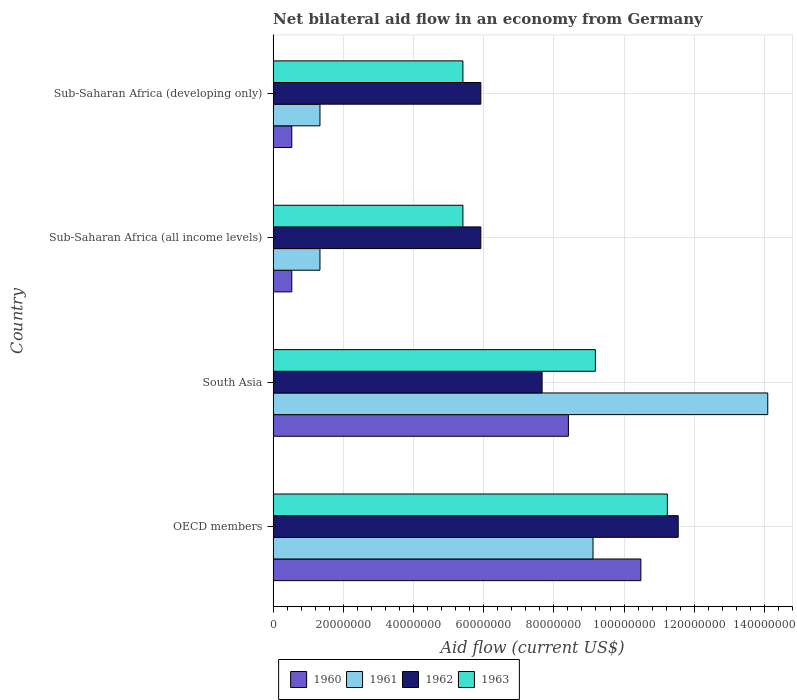Are the number of bars on each tick of the Y-axis equal?
Offer a terse response. Yes. How many bars are there on the 2nd tick from the top?
Your response must be concise. 4. What is the label of the 2nd group of bars from the top?
Offer a very short reply. Sub-Saharan Africa (all income levels). What is the net bilateral aid flow in 1961 in OECD members?
Offer a terse response. 9.12e+07. Across all countries, what is the maximum net bilateral aid flow in 1961?
Give a very brief answer. 1.41e+08. Across all countries, what is the minimum net bilateral aid flow in 1961?
Your response must be concise. 1.34e+07. In which country was the net bilateral aid flow in 1962 maximum?
Keep it short and to the point. OECD members. In which country was the net bilateral aid flow in 1962 minimum?
Your answer should be compact. Sub-Saharan Africa (all income levels). What is the total net bilateral aid flow in 1961 in the graph?
Keep it short and to the point. 2.59e+08. What is the difference between the net bilateral aid flow in 1961 in OECD members and that in South Asia?
Give a very brief answer. -4.98e+07. What is the difference between the net bilateral aid flow in 1962 in South Asia and the net bilateral aid flow in 1963 in OECD members?
Your answer should be compact. -3.57e+07. What is the average net bilateral aid flow in 1962 per country?
Ensure brevity in your answer.  7.76e+07. What is the difference between the net bilateral aid flow in 1961 and net bilateral aid flow in 1960 in Sub-Saharan Africa (developing only)?
Provide a succinct answer. 8.03e+06. In how many countries, is the net bilateral aid flow in 1960 greater than 20000000 US$?
Provide a succinct answer. 2. What is the ratio of the net bilateral aid flow in 1962 in OECD members to that in South Asia?
Make the answer very short. 1.51. Is the difference between the net bilateral aid flow in 1961 in OECD members and Sub-Saharan Africa (all income levels) greater than the difference between the net bilateral aid flow in 1960 in OECD members and Sub-Saharan Africa (all income levels)?
Offer a terse response. No. What is the difference between the highest and the second highest net bilateral aid flow in 1963?
Ensure brevity in your answer.  2.05e+07. What is the difference between the highest and the lowest net bilateral aid flow in 1963?
Make the answer very short. 5.83e+07. In how many countries, is the net bilateral aid flow in 1961 greater than the average net bilateral aid flow in 1961 taken over all countries?
Provide a succinct answer. 2. What does the 2nd bar from the top in Sub-Saharan Africa (all income levels) represents?
Give a very brief answer. 1962. What does the 4th bar from the bottom in South Asia represents?
Make the answer very short. 1963. Is it the case that in every country, the sum of the net bilateral aid flow in 1963 and net bilateral aid flow in 1960 is greater than the net bilateral aid flow in 1961?
Keep it short and to the point. Yes. How many bars are there?
Your response must be concise. 16. How many countries are there in the graph?
Give a very brief answer. 4. Are the values on the major ticks of X-axis written in scientific E-notation?
Offer a terse response. No. Does the graph contain grids?
Your answer should be compact. Yes. How many legend labels are there?
Make the answer very short. 4. What is the title of the graph?
Your answer should be very brief. Net bilateral aid flow in an economy from Germany. What is the Aid flow (current US$) in 1960 in OECD members?
Offer a very short reply. 1.05e+08. What is the Aid flow (current US$) of 1961 in OECD members?
Make the answer very short. 9.12e+07. What is the Aid flow (current US$) in 1962 in OECD members?
Keep it short and to the point. 1.15e+08. What is the Aid flow (current US$) in 1963 in OECD members?
Ensure brevity in your answer.  1.12e+08. What is the Aid flow (current US$) of 1960 in South Asia?
Make the answer very short. 8.42e+07. What is the Aid flow (current US$) in 1961 in South Asia?
Offer a very short reply. 1.41e+08. What is the Aid flow (current US$) of 1962 in South Asia?
Ensure brevity in your answer.  7.66e+07. What is the Aid flow (current US$) of 1963 in South Asia?
Make the answer very short. 9.18e+07. What is the Aid flow (current US$) in 1960 in Sub-Saharan Africa (all income levels)?
Your answer should be compact. 5.32e+06. What is the Aid flow (current US$) of 1961 in Sub-Saharan Africa (all income levels)?
Your response must be concise. 1.34e+07. What is the Aid flow (current US$) of 1962 in Sub-Saharan Africa (all income levels)?
Your answer should be very brief. 5.92e+07. What is the Aid flow (current US$) of 1963 in Sub-Saharan Africa (all income levels)?
Ensure brevity in your answer.  5.41e+07. What is the Aid flow (current US$) in 1960 in Sub-Saharan Africa (developing only)?
Give a very brief answer. 5.32e+06. What is the Aid flow (current US$) of 1961 in Sub-Saharan Africa (developing only)?
Ensure brevity in your answer.  1.34e+07. What is the Aid flow (current US$) of 1962 in Sub-Saharan Africa (developing only)?
Provide a succinct answer. 5.92e+07. What is the Aid flow (current US$) in 1963 in Sub-Saharan Africa (developing only)?
Your answer should be very brief. 5.41e+07. Across all countries, what is the maximum Aid flow (current US$) of 1960?
Offer a terse response. 1.05e+08. Across all countries, what is the maximum Aid flow (current US$) in 1961?
Make the answer very short. 1.41e+08. Across all countries, what is the maximum Aid flow (current US$) in 1962?
Offer a very short reply. 1.15e+08. Across all countries, what is the maximum Aid flow (current US$) in 1963?
Offer a very short reply. 1.12e+08. Across all countries, what is the minimum Aid flow (current US$) of 1960?
Offer a very short reply. 5.32e+06. Across all countries, what is the minimum Aid flow (current US$) of 1961?
Your answer should be compact. 1.34e+07. Across all countries, what is the minimum Aid flow (current US$) in 1962?
Offer a terse response. 5.92e+07. Across all countries, what is the minimum Aid flow (current US$) of 1963?
Provide a short and direct response. 5.41e+07. What is the total Aid flow (current US$) of 1960 in the graph?
Your answer should be compact. 2.00e+08. What is the total Aid flow (current US$) of 1961 in the graph?
Ensure brevity in your answer.  2.59e+08. What is the total Aid flow (current US$) in 1962 in the graph?
Offer a terse response. 3.10e+08. What is the total Aid flow (current US$) of 1963 in the graph?
Make the answer very short. 3.12e+08. What is the difference between the Aid flow (current US$) in 1960 in OECD members and that in South Asia?
Keep it short and to the point. 2.06e+07. What is the difference between the Aid flow (current US$) of 1961 in OECD members and that in South Asia?
Keep it short and to the point. -4.98e+07. What is the difference between the Aid flow (current US$) of 1962 in OECD members and that in South Asia?
Offer a very short reply. 3.88e+07. What is the difference between the Aid flow (current US$) of 1963 in OECD members and that in South Asia?
Your response must be concise. 2.05e+07. What is the difference between the Aid flow (current US$) in 1960 in OECD members and that in Sub-Saharan Africa (all income levels)?
Your answer should be very brief. 9.95e+07. What is the difference between the Aid flow (current US$) in 1961 in OECD members and that in Sub-Saharan Africa (all income levels)?
Ensure brevity in your answer.  7.78e+07. What is the difference between the Aid flow (current US$) in 1962 in OECD members and that in Sub-Saharan Africa (all income levels)?
Your answer should be compact. 5.62e+07. What is the difference between the Aid flow (current US$) in 1963 in OECD members and that in Sub-Saharan Africa (all income levels)?
Your answer should be compact. 5.83e+07. What is the difference between the Aid flow (current US$) in 1960 in OECD members and that in Sub-Saharan Africa (developing only)?
Give a very brief answer. 9.95e+07. What is the difference between the Aid flow (current US$) in 1961 in OECD members and that in Sub-Saharan Africa (developing only)?
Provide a short and direct response. 7.78e+07. What is the difference between the Aid flow (current US$) in 1962 in OECD members and that in Sub-Saharan Africa (developing only)?
Make the answer very short. 5.62e+07. What is the difference between the Aid flow (current US$) of 1963 in OECD members and that in Sub-Saharan Africa (developing only)?
Offer a terse response. 5.83e+07. What is the difference between the Aid flow (current US$) in 1960 in South Asia and that in Sub-Saharan Africa (all income levels)?
Keep it short and to the point. 7.88e+07. What is the difference between the Aid flow (current US$) of 1961 in South Asia and that in Sub-Saharan Africa (all income levels)?
Your answer should be very brief. 1.28e+08. What is the difference between the Aid flow (current US$) in 1962 in South Asia and that in Sub-Saharan Africa (all income levels)?
Provide a succinct answer. 1.75e+07. What is the difference between the Aid flow (current US$) of 1963 in South Asia and that in Sub-Saharan Africa (all income levels)?
Ensure brevity in your answer.  3.78e+07. What is the difference between the Aid flow (current US$) in 1960 in South Asia and that in Sub-Saharan Africa (developing only)?
Give a very brief answer. 7.88e+07. What is the difference between the Aid flow (current US$) of 1961 in South Asia and that in Sub-Saharan Africa (developing only)?
Give a very brief answer. 1.28e+08. What is the difference between the Aid flow (current US$) in 1962 in South Asia and that in Sub-Saharan Africa (developing only)?
Your response must be concise. 1.75e+07. What is the difference between the Aid flow (current US$) in 1963 in South Asia and that in Sub-Saharan Africa (developing only)?
Provide a succinct answer. 3.78e+07. What is the difference between the Aid flow (current US$) of 1962 in Sub-Saharan Africa (all income levels) and that in Sub-Saharan Africa (developing only)?
Your answer should be very brief. 0. What is the difference between the Aid flow (current US$) in 1963 in Sub-Saharan Africa (all income levels) and that in Sub-Saharan Africa (developing only)?
Make the answer very short. 0. What is the difference between the Aid flow (current US$) in 1960 in OECD members and the Aid flow (current US$) in 1961 in South Asia?
Provide a succinct answer. -3.62e+07. What is the difference between the Aid flow (current US$) in 1960 in OECD members and the Aid flow (current US$) in 1962 in South Asia?
Offer a terse response. 2.82e+07. What is the difference between the Aid flow (current US$) of 1960 in OECD members and the Aid flow (current US$) of 1963 in South Asia?
Make the answer very short. 1.30e+07. What is the difference between the Aid flow (current US$) of 1961 in OECD members and the Aid flow (current US$) of 1962 in South Asia?
Your answer should be compact. 1.45e+07. What is the difference between the Aid flow (current US$) in 1961 in OECD members and the Aid flow (current US$) in 1963 in South Asia?
Give a very brief answer. -6.80e+05. What is the difference between the Aid flow (current US$) of 1962 in OECD members and the Aid flow (current US$) of 1963 in South Asia?
Offer a terse response. 2.36e+07. What is the difference between the Aid flow (current US$) of 1960 in OECD members and the Aid flow (current US$) of 1961 in Sub-Saharan Africa (all income levels)?
Keep it short and to the point. 9.14e+07. What is the difference between the Aid flow (current US$) in 1960 in OECD members and the Aid flow (current US$) in 1962 in Sub-Saharan Africa (all income levels)?
Offer a terse response. 4.56e+07. What is the difference between the Aid flow (current US$) of 1960 in OECD members and the Aid flow (current US$) of 1963 in Sub-Saharan Africa (all income levels)?
Provide a short and direct response. 5.07e+07. What is the difference between the Aid flow (current US$) in 1961 in OECD members and the Aid flow (current US$) in 1962 in Sub-Saharan Africa (all income levels)?
Keep it short and to the point. 3.20e+07. What is the difference between the Aid flow (current US$) in 1961 in OECD members and the Aid flow (current US$) in 1963 in Sub-Saharan Africa (all income levels)?
Offer a very short reply. 3.71e+07. What is the difference between the Aid flow (current US$) in 1962 in OECD members and the Aid flow (current US$) in 1963 in Sub-Saharan Africa (all income levels)?
Make the answer very short. 6.14e+07. What is the difference between the Aid flow (current US$) of 1960 in OECD members and the Aid flow (current US$) of 1961 in Sub-Saharan Africa (developing only)?
Your answer should be compact. 9.14e+07. What is the difference between the Aid flow (current US$) of 1960 in OECD members and the Aid flow (current US$) of 1962 in Sub-Saharan Africa (developing only)?
Make the answer very short. 4.56e+07. What is the difference between the Aid flow (current US$) in 1960 in OECD members and the Aid flow (current US$) in 1963 in Sub-Saharan Africa (developing only)?
Provide a succinct answer. 5.07e+07. What is the difference between the Aid flow (current US$) of 1961 in OECD members and the Aid flow (current US$) of 1962 in Sub-Saharan Africa (developing only)?
Offer a terse response. 3.20e+07. What is the difference between the Aid flow (current US$) in 1961 in OECD members and the Aid flow (current US$) in 1963 in Sub-Saharan Africa (developing only)?
Ensure brevity in your answer.  3.71e+07. What is the difference between the Aid flow (current US$) of 1962 in OECD members and the Aid flow (current US$) of 1963 in Sub-Saharan Africa (developing only)?
Keep it short and to the point. 6.14e+07. What is the difference between the Aid flow (current US$) in 1960 in South Asia and the Aid flow (current US$) in 1961 in Sub-Saharan Africa (all income levels)?
Give a very brief answer. 7.08e+07. What is the difference between the Aid flow (current US$) of 1960 in South Asia and the Aid flow (current US$) of 1962 in Sub-Saharan Africa (all income levels)?
Offer a terse response. 2.50e+07. What is the difference between the Aid flow (current US$) of 1960 in South Asia and the Aid flow (current US$) of 1963 in Sub-Saharan Africa (all income levels)?
Provide a succinct answer. 3.01e+07. What is the difference between the Aid flow (current US$) of 1961 in South Asia and the Aid flow (current US$) of 1962 in Sub-Saharan Africa (all income levels)?
Offer a very short reply. 8.18e+07. What is the difference between the Aid flow (current US$) of 1961 in South Asia and the Aid flow (current US$) of 1963 in Sub-Saharan Africa (all income levels)?
Give a very brief answer. 8.69e+07. What is the difference between the Aid flow (current US$) of 1962 in South Asia and the Aid flow (current US$) of 1963 in Sub-Saharan Africa (all income levels)?
Provide a succinct answer. 2.26e+07. What is the difference between the Aid flow (current US$) of 1960 in South Asia and the Aid flow (current US$) of 1961 in Sub-Saharan Africa (developing only)?
Give a very brief answer. 7.08e+07. What is the difference between the Aid flow (current US$) in 1960 in South Asia and the Aid flow (current US$) in 1962 in Sub-Saharan Africa (developing only)?
Offer a very short reply. 2.50e+07. What is the difference between the Aid flow (current US$) in 1960 in South Asia and the Aid flow (current US$) in 1963 in Sub-Saharan Africa (developing only)?
Your response must be concise. 3.01e+07. What is the difference between the Aid flow (current US$) in 1961 in South Asia and the Aid flow (current US$) in 1962 in Sub-Saharan Africa (developing only)?
Offer a terse response. 8.18e+07. What is the difference between the Aid flow (current US$) in 1961 in South Asia and the Aid flow (current US$) in 1963 in Sub-Saharan Africa (developing only)?
Keep it short and to the point. 8.69e+07. What is the difference between the Aid flow (current US$) in 1962 in South Asia and the Aid flow (current US$) in 1963 in Sub-Saharan Africa (developing only)?
Your answer should be compact. 2.26e+07. What is the difference between the Aid flow (current US$) of 1960 in Sub-Saharan Africa (all income levels) and the Aid flow (current US$) of 1961 in Sub-Saharan Africa (developing only)?
Your answer should be very brief. -8.03e+06. What is the difference between the Aid flow (current US$) of 1960 in Sub-Saharan Africa (all income levels) and the Aid flow (current US$) of 1962 in Sub-Saharan Africa (developing only)?
Make the answer very short. -5.39e+07. What is the difference between the Aid flow (current US$) in 1960 in Sub-Saharan Africa (all income levels) and the Aid flow (current US$) in 1963 in Sub-Saharan Africa (developing only)?
Your response must be concise. -4.88e+07. What is the difference between the Aid flow (current US$) of 1961 in Sub-Saharan Africa (all income levels) and the Aid flow (current US$) of 1962 in Sub-Saharan Africa (developing only)?
Give a very brief answer. -4.58e+07. What is the difference between the Aid flow (current US$) in 1961 in Sub-Saharan Africa (all income levels) and the Aid flow (current US$) in 1963 in Sub-Saharan Africa (developing only)?
Offer a terse response. -4.07e+07. What is the difference between the Aid flow (current US$) of 1962 in Sub-Saharan Africa (all income levels) and the Aid flow (current US$) of 1963 in Sub-Saharan Africa (developing only)?
Provide a succinct answer. 5.10e+06. What is the average Aid flow (current US$) in 1960 per country?
Ensure brevity in your answer.  4.99e+07. What is the average Aid flow (current US$) in 1961 per country?
Your answer should be very brief. 6.47e+07. What is the average Aid flow (current US$) in 1962 per country?
Offer a very short reply. 7.76e+07. What is the average Aid flow (current US$) in 1963 per country?
Give a very brief answer. 7.81e+07. What is the difference between the Aid flow (current US$) of 1960 and Aid flow (current US$) of 1961 in OECD members?
Keep it short and to the point. 1.36e+07. What is the difference between the Aid flow (current US$) in 1960 and Aid flow (current US$) in 1962 in OECD members?
Provide a short and direct response. -1.06e+07. What is the difference between the Aid flow (current US$) in 1960 and Aid flow (current US$) in 1963 in OECD members?
Keep it short and to the point. -7.55e+06. What is the difference between the Aid flow (current US$) of 1961 and Aid flow (current US$) of 1962 in OECD members?
Keep it short and to the point. -2.43e+07. What is the difference between the Aid flow (current US$) of 1961 and Aid flow (current US$) of 1963 in OECD members?
Ensure brevity in your answer.  -2.12e+07. What is the difference between the Aid flow (current US$) of 1962 and Aid flow (current US$) of 1963 in OECD members?
Make the answer very short. 3.09e+06. What is the difference between the Aid flow (current US$) of 1960 and Aid flow (current US$) of 1961 in South Asia?
Keep it short and to the point. -5.68e+07. What is the difference between the Aid flow (current US$) in 1960 and Aid flow (current US$) in 1962 in South Asia?
Provide a succinct answer. 7.50e+06. What is the difference between the Aid flow (current US$) of 1960 and Aid flow (current US$) of 1963 in South Asia?
Ensure brevity in your answer.  -7.69e+06. What is the difference between the Aid flow (current US$) of 1961 and Aid flow (current US$) of 1962 in South Asia?
Make the answer very short. 6.43e+07. What is the difference between the Aid flow (current US$) of 1961 and Aid flow (current US$) of 1963 in South Asia?
Offer a very short reply. 4.91e+07. What is the difference between the Aid flow (current US$) in 1962 and Aid flow (current US$) in 1963 in South Asia?
Offer a very short reply. -1.52e+07. What is the difference between the Aid flow (current US$) in 1960 and Aid flow (current US$) in 1961 in Sub-Saharan Africa (all income levels)?
Your answer should be compact. -8.03e+06. What is the difference between the Aid flow (current US$) in 1960 and Aid flow (current US$) in 1962 in Sub-Saharan Africa (all income levels)?
Your response must be concise. -5.39e+07. What is the difference between the Aid flow (current US$) of 1960 and Aid flow (current US$) of 1963 in Sub-Saharan Africa (all income levels)?
Your response must be concise. -4.88e+07. What is the difference between the Aid flow (current US$) in 1961 and Aid flow (current US$) in 1962 in Sub-Saharan Africa (all income levels)?
Your answer should be very brief. -4.58e+07. What is the difference between the Aid flow (current US$) in 1961 and Aid flow (current US$) in 1963 in Sub-Saharan Africa (all income levels)?
Your answer should be compact. -4.07e+07. What is the difference between the Aid flow (current US$) of 1962 and Aid flow (current US$) of 1963 in Sub-Saharan Africa (all income levels)?
Ensure brevity in your answer.  5.10e+06. What is the difference between the Aid flow (current US$) of 1960 and Aid flow (current US$) of 1961 in Sub-Saharan Africa (developing only)?
Make the answer very short. -8.03e+06. What is the difference between the Aid flow (current US$) in 1960 and Aid flow (current US$) in 1962 in Sub-Saharan Africa (developing only)?
Your answer should be very brief. -5.39e+07. What is the difference between the Aid flow (current US$) of 1960 and Aid flow (current US$) of 1963 in Sub-Saharan Africa (developing only)?
Your response must be concise. -4.88e+07. What is the difference between the Aid flow (current US$) of 1961 and Aid flow (current US$) of 1962 in Sub-Saharan Africa (developing only)?
Make the answer very short. -4.58e+07. What is the difference between the Aid flow (current US$) of 1961 and Aid flow (current US$) of 1963 in Sub-Saharan Africa (developing only)?
Your answer should be compact. -4.07e+07. What is the difference between the Aid flow (current US$) of 1962 and Aid flow (current US$) of 1963 in Sub-Saharan Africa (developing only)?
Offer a terse response. 5.10e+06. What is the ratio of the Aid flow (current US$) of 1960 in OECD members to that in South Asia?
Your response must be concise. 1.25. What is the ratio of the Aid flow (current US$) in 1961 in OECD members to that in South Asia?
Your answer should be very brief. 0.65. What is the ratio of the Aid flow (current US$) in 1962 in OECD members to that in South Asia?
Keep it short and to the point. 1.51. What is the ratio of the Aid flow (current US$) of 1963 in OECD members to that in South Asia?
Your response must be concise. 1.22. What is the ratio of the Aid flow (current US$) in 1960 in OECD members to that in Sub-Saharan Africa (all income levels)?
Your answer should be compact. 19.7. What is the ratio of the Aid flow (current US$) in 1961 in OECD members to that in Sub-Saharan Africa (all income levels)?
Make the answer very short. 6.83. What is the ratio of the Aid flow (current US$) of 1962 in OECD members to that in Sub-Saharan Africa (all income levels)?
Ensure brevity in your answer.  1.95. What is the ratio of the Aid flow (current US$) in 1963 in OECD members to that in Sub-Saharan Africa (all income levels)?
Provide a succinct answer. 2.08. What is the ratio of the Aid flow (current US$) in 1960 in OECD members to that in Sub-Saharan Africa (developing only)?
Offer a very short reply. 19.7. What is the ratio of the Aid flow (current US$) in 1961 in OECD members to that in Sub-Saharan Africa (developing only)?
Make the answer very short. 6.83. What is the ratio of the Aid flow (current US$) of 1962 in OECD members to that in Sub-Saharan Africa (developing only)?
Your response must be concise. 1.95. What is the ratio of the Aid flow (current US$) in 1963 in OECD members to that in Sub-Saharan Africa (developing only)?
Your answer should be compact. 2.08. What is the ratio of the Aid flow (current US$) of 1960 in South Asia to that in Sub-Saharan Africa (all income levels)?
Your answer should be very brief. 15.82. What is the ratio of the Aid flow (current US$) in 1961 in South Asia to that in Sub-Saharan Africa (all income levels)?
Your response must be concise. 10.56. What is the ratio of the Aid flow (current US$) in 1962 in South Asia to that in Sub-Saharan Africa (all income levels)?
Give a very brief answer. 1.29. What is the ratio of the Aid flow (current US$) of 1963 in South Asia to that in Sub-Saharan Africa (all income levels)?
Give a very brief answer. 1.7. What is the ratio of the Aid flow (current US$) in 1960 in South Asia to that in Sub-Saharan Africa (developing only)?
Your answer should be very brief. 15.82. What is the ratio of the Aid flow (current US$) of 1961 in South Asia to that in Sub-Saharan Africa (developing only)?
Provide a succinct answer. 10.56. What is the ratio of the Aid flow (current US$) in 1962 in South Asia to that in Sub-Saharan Africa (developing only)?
Keep it short and to the point. 1.29. What is the ratio of the Aid flow (current US$) of 1963 in South Asia to that in Sub-Saharan Africa (developing only)?
Give a very brief answer. 1.7. What is the ratio of the Aid flow (current US$) in 1960 in Sub-Saharan Africa (all income levels) to that in Sub-Saharan Africa (developing only)?
Offer a terse response. 1. What is the ratio of the Aid flow (current US$) in 1961 in Sub-Saharan Africa (all income levels) to that in Sub-Saharan Africa (developing only)?
Keep it short and to the point. 1. What is the difference between the highest and the second highest Aid flow (current US$) in 1960?
Offer a very short reply. 2.06e+07. What is the difference between the highest and the second highest Aid flow (current US$) of 1961?
Your answer should be very brief. 4.98e+07. What is the difference between the highest and the second highest Aid flow (current US$) of 1962?
Provide a succinct answer. 3.88e+07. What is the difference between the highest and the second highest Aid flow (current US$) in 1963?
Make the answer very short. 2.05e+07. What is the difference between the highest and the lowest Aid flow (current US$) of 1960?
Keep it short and to the point. 9.95e+07. What is the difference between the highest and the lowest Aid flow (current US$) of 1961?
Keep it short and to the point. 1.28e+08. What is the difference between the highest and the lowest Aid flow (current US$) in 1962?
Make the answer very short. 5.62e+07. What is the difference between the highest and the lowest Aid flow (current US$) in 1963?
Your response must be concise. 5.83e+07. 